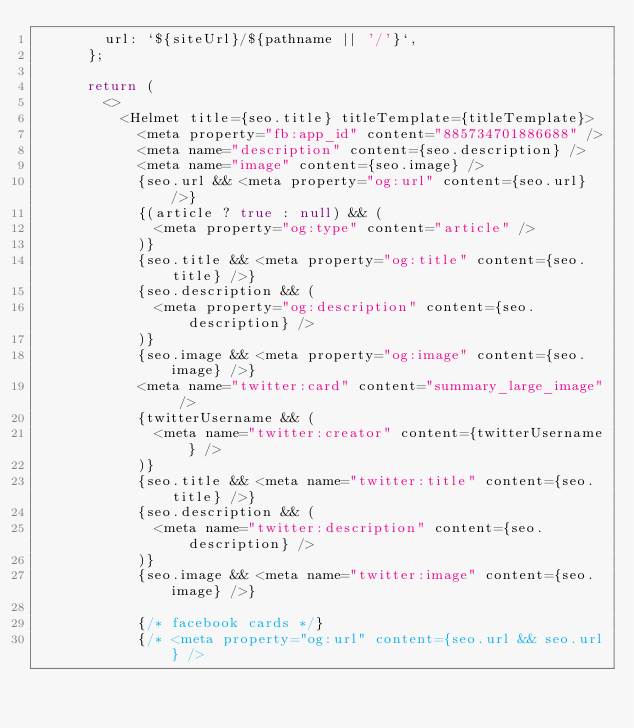<code> <loc_0><loc_0><loc_500><loc_500><_JavaScript_>        url: `${siteUrl}/${pathname || '/'}`,
      };

      return (
        <>
          <Helmet title={seo.title} titleTemplate={titleTemplate}>
            <meta property="fb:app_id" content="885734701886688" />
            <meta name="description" content={seo.description} />
            <meta name="image" content={seo.image} />
            {seo.url && <meta property="og:url" content={seo.url} />}
            {(article ? true : null) && (
              <meta property="og:type" content="article" />
            )}
            {seo.title && <meta property="og:title" content={seo.title} />}
            {seo.description && (
              <meta property="og:description" content={seo.description} />
            )}
            {seo.image && <meta property="og:image" content={seo.image} />}
            <meta name="twitter:card" content="summary_large_image" />
            {twitterUsername && (
              <meta name="twitter:creator" content={twitterUsername} />
            )}
            {seo.title && <meta name="twitter:title" content={seo.title} />}
            {seo.description && (
              <meta name="twitter:description" content={seo.description} />
            )}
            {seo.image && <meta name="twitter:image" content={seo.image} />}

            {/* facebook cards */}
            {/* <meta property="og:url" content={seo.url && seo.url} /></code> 